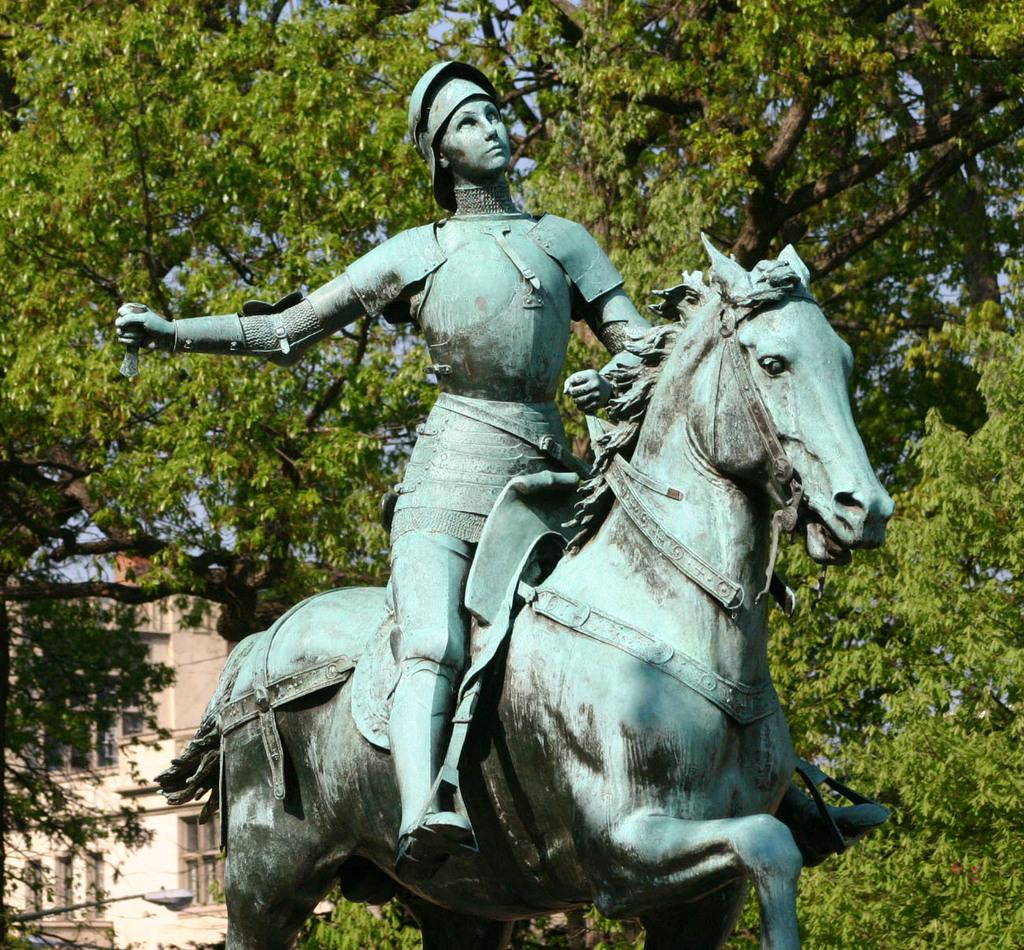What is the main subject of the image? There is a statue of a person riding a horse in the image. What can be seen in the background of the image? There are trees and a building in the background of the image. What type of nose can be seen on the horse in the image? There is no nose visible on the horse in the image, as it is a statue. What nation is represented by the statue in the image? The image does not provide enough information to determine which nation the statue represents. 